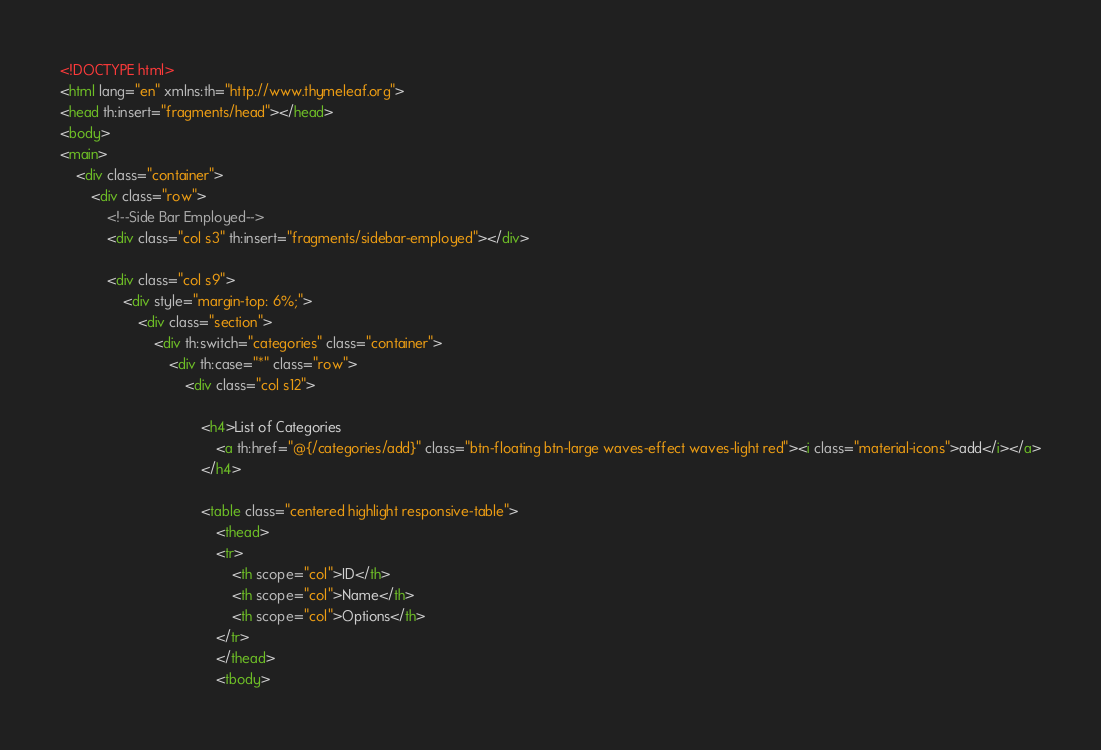<code> <loc_0><loc_0><loc_500><loc_500><_HTML_><!DOCTYPE html>
<html lang="en" xmlns:th="http://www.thymeleaf.org">
<head th:insert="fragments/head"></head>
<body>
<main>
    <div class="container">
        <div class="row">
            <!--Side Bar Employed-->
            <div class="col s3" th:insert="fragments/sidebar-employed"></div>

            <div class="col s9">
                <div style="margin-top: 6%;">
                    <div class="section">
                        <div th:switch="categories" class="container">
                            <div th:case="*" class="row">
                                <div class="col s12">

                                    <h4>List of Categories
                                        <a th:href="@{/categories/add}" class="btn-floating btn-large waves-effect waves-light red"><i class="material-icons">add</i></a>
                                    </h4>

                                    <table class="centered highlight responsive-table">
                                        <thead>
                                        <tr>
                                            <th scope="col">ID</th>
                                            <th scope="col">Name</th>
                                            <th scope="col">Options</th>
                                        </tr>
                                        </thead>
                                        <tbody></code> 